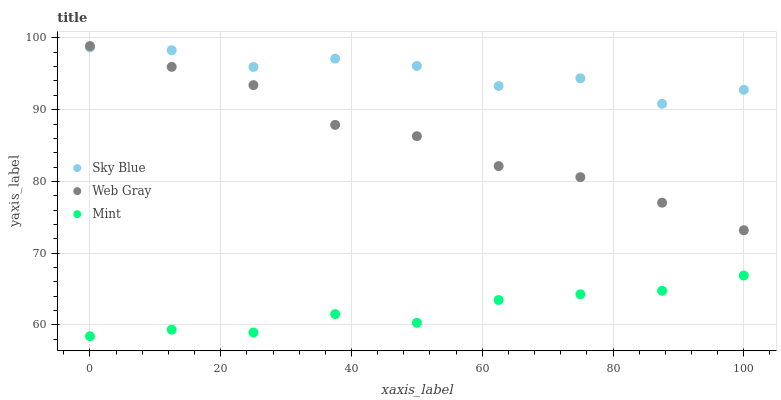Does Mint have the minimum area under the curve?
Answer yes or no. Yes. Does Sky Blue have the maximum area under the curve?
Answer yes or no. Yes. Does Web Gray have the minimum area under the curve?
Answer yes or no. No. Does Web Gray have the maximum area under the curve?
Answer yes or no. No. Is Web Gray the smoothest?
Answer yes or no. Yes. Is Sky Blue the roughest?
Answer yes or no. Yes. Is Mint the smoothest?
Answer yes or no. No. Is Mint the roughest?
Answer yes or no. No. Does Mint have the lowest value?
Answer yes or no. Yes. Does Web Gray have the lowest value?
Answer yes or no. No. Does Web Gray have the highest value?
Answer yes or no. Yes. Does Mint have the highest value?
Answer yes or no. No. Is Mint less than Sky Blue?
Answer yes or no. Yes. Is Sky Blue greater than Mint?
Answer yes or no. Yes. Does Sky Blue intersect Web Gray?
Answer yes or no. Yes. Is Sky Blue less than Web Gray?
Answer yes or no. No. Is Sky Blue greater than Web Gray?
Answer yes or no. No. Does Mint intersect Sky Blue?
Answer yes or no. No. 